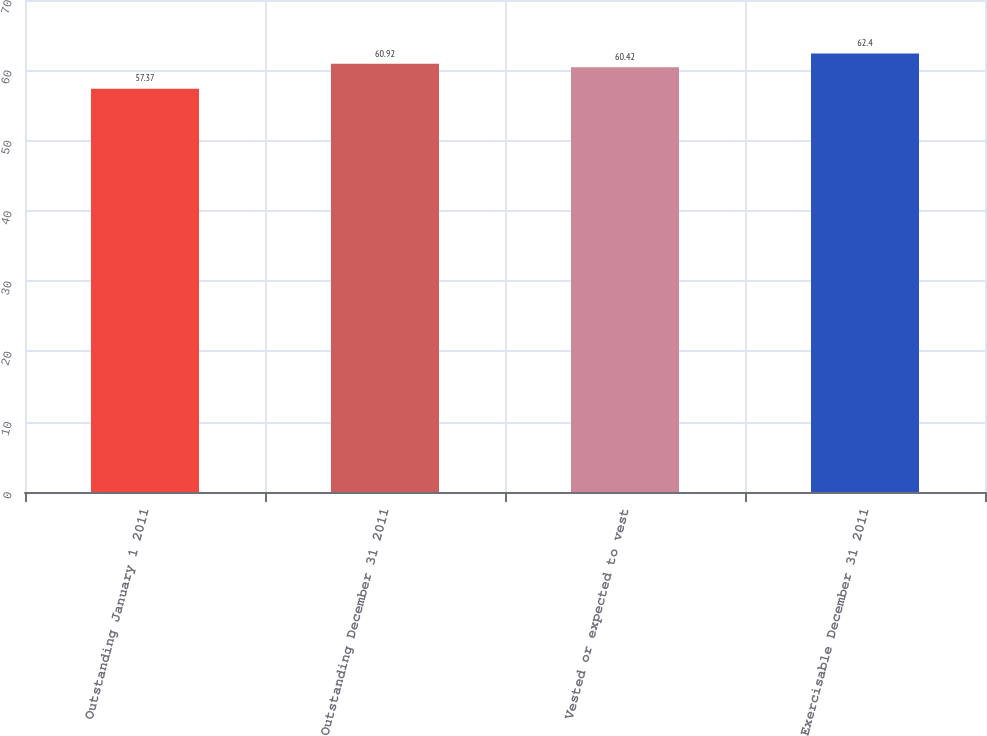<chart> <loc_0><loc_0><loc_500><loc_500><bar_chart><fcel>Outstanding January 1 2011<fcel>Outstanding December 31 2011<fcel>Vested or expected to vest<fcel>Exercisable December 31 2011<nl><fcel>57.37<fcel>60.92<fcel>60.42<fcel>62.4<nl></chart> 